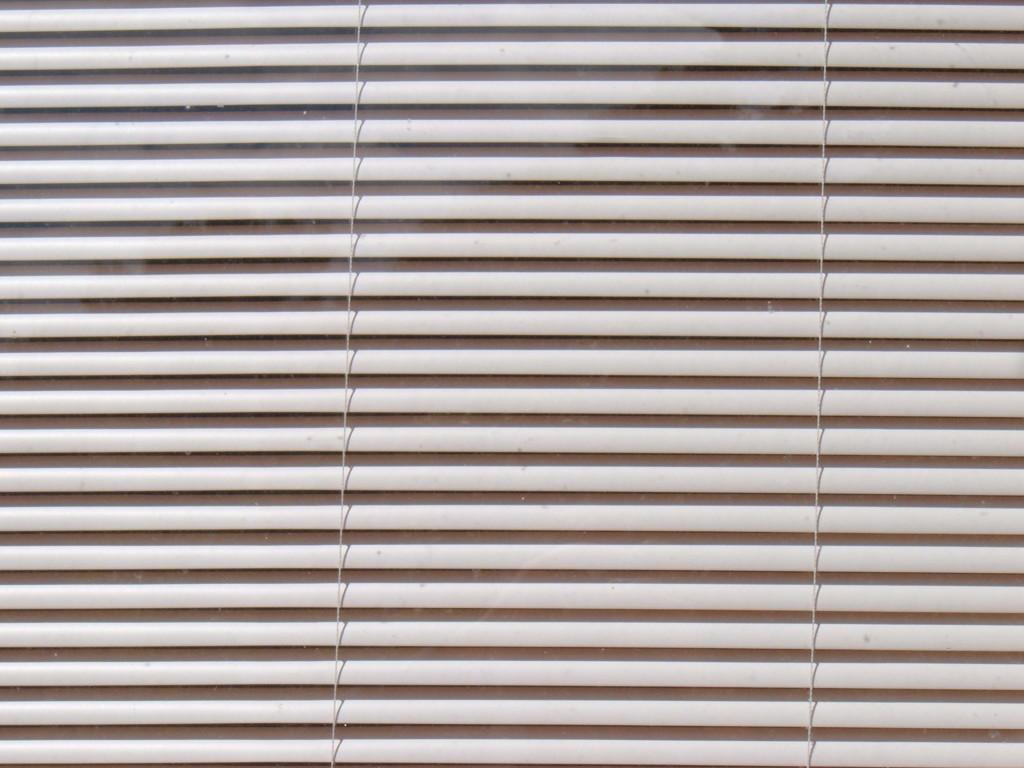What is the color of the object in the image? The object in the image is white. What type of object is it? The object seems to be a window blind. How many hens are visible in the image? There are no hens present in the image; it features a white object that appears to be a window blind. 